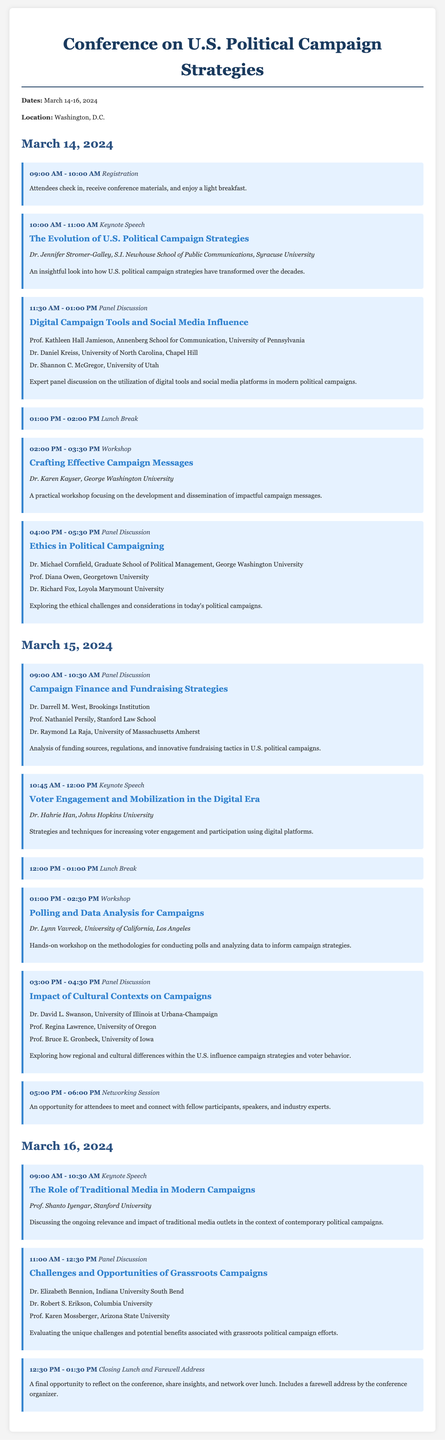What are the conference dates? The conference dates are explicitly mentioned in the document as March 14-16, 2024.
Answer: March 14-16, 2024 Who is the keynote speaker for the first day? The keynote speaker for the first day is listed with their title and description, found in the event section for March 14 at 10:00 AM.
Answer: Dr. Jennifer Stromer-Galley What time does the registration start? The registration time is clearly indicated in the first event listed for March 14, 2024.
Answer: 09:00 AM What is the main topic of the panel discussion on March 15 at 3:00 PM? The topic of the panel discussion is provided in the event title for March 15 at 3:00 PM.
Answer: Impact of Cultural Contexts on Campaigns How many panel speakers are there for the "Ethics in Political Campaigning" discussion? The number of speakers can be determined by counting the list provided in the respective event details.
Answer: Three What is the lunch break duration on March 14? The lunch break duration is a specified time range shown in the events list on March 14, 2024.
Answer: 01:00 PM - 02:00 PM Who is moderating the workshop on polling and data analysis? The workshop details list the speaker's name clearly in the event section for March 15 at 01:00 PM.
Answer: Dr. Lynn Vavreck What is included in the closing session on March 16? The closing session description mentions it includes a farewell address by the conference organizer.
Answer: Farewell address What will be discussed in the keynote speech on March 16 at 09:00 AM? The topic of discussion is articulated in the title and description of the event on that date.
Answer: The Role of Traditional Media in Modern Campaigns 